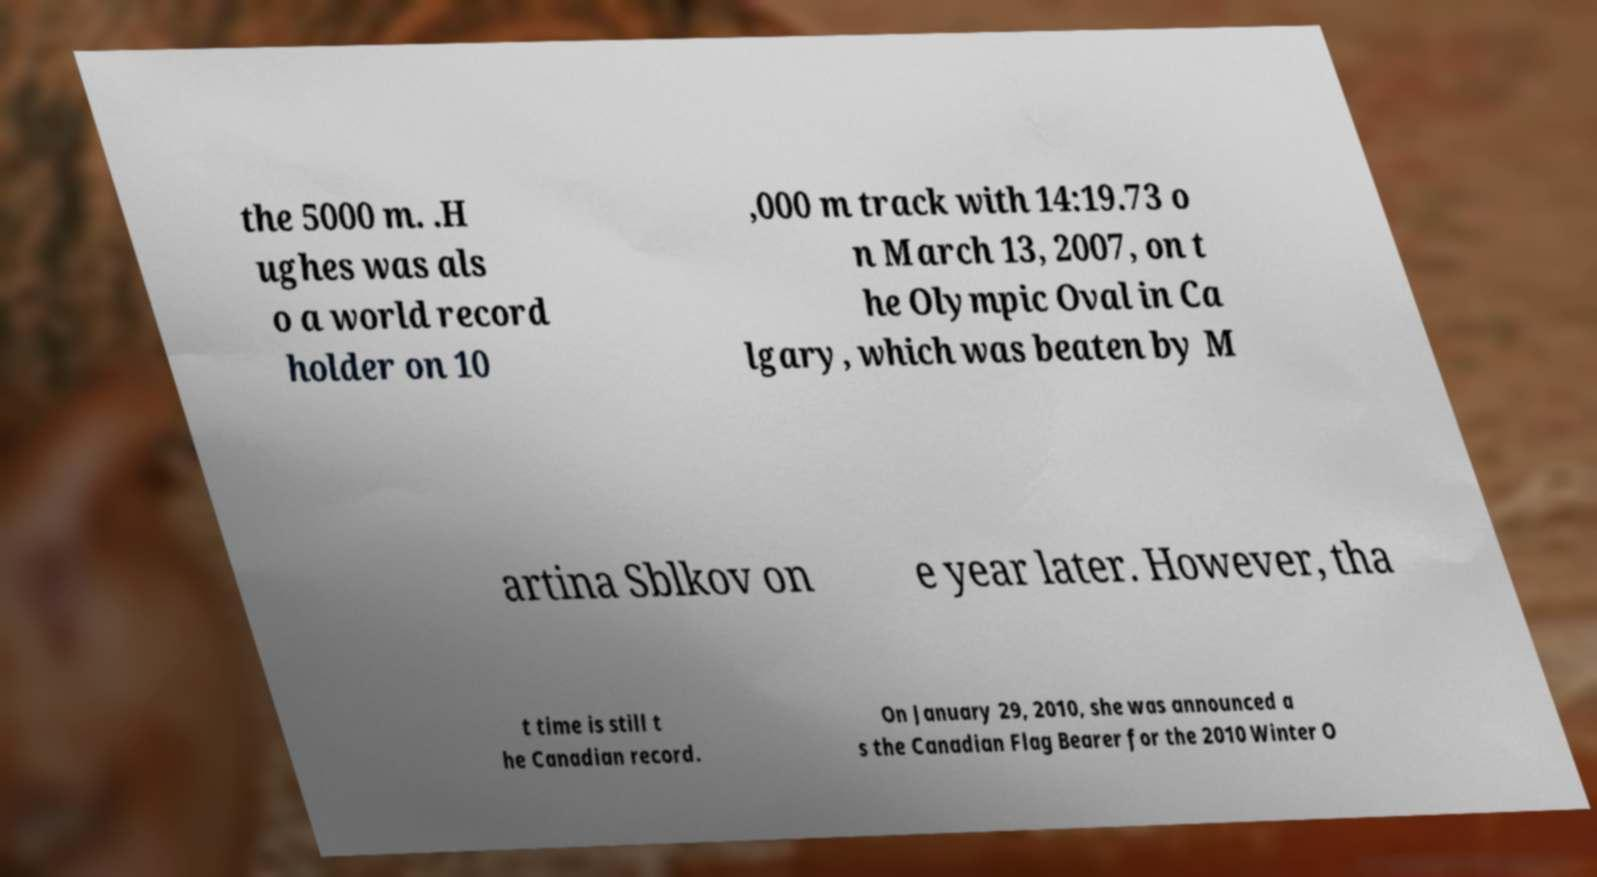Can you read and provide the text displayed in the image?This photo seems to have some interesting text. Can you extract and type it out for me? the 5000 m. .H ughes was als o a world record holder on 10 ,000 m track with 14:19.73 o n March 13, 2007, on t he Olympic Oval in Ca lgary, which was beaten by M artina Sblkov on e year later. However, tha t time is still t he Canadian record. On January 29, 2010, she was announced a s the Canadian Flag Bearer for the 2010 Winter O 